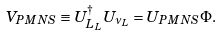<formula> <loc_0><loc_0><loc_500><loc_500>V _ { P M N S } \equiv U ^ { \dagger } _ { L _ { L } } U _ { \nu _ { L } } = U _ { P M N S } \Phi .</formula> 